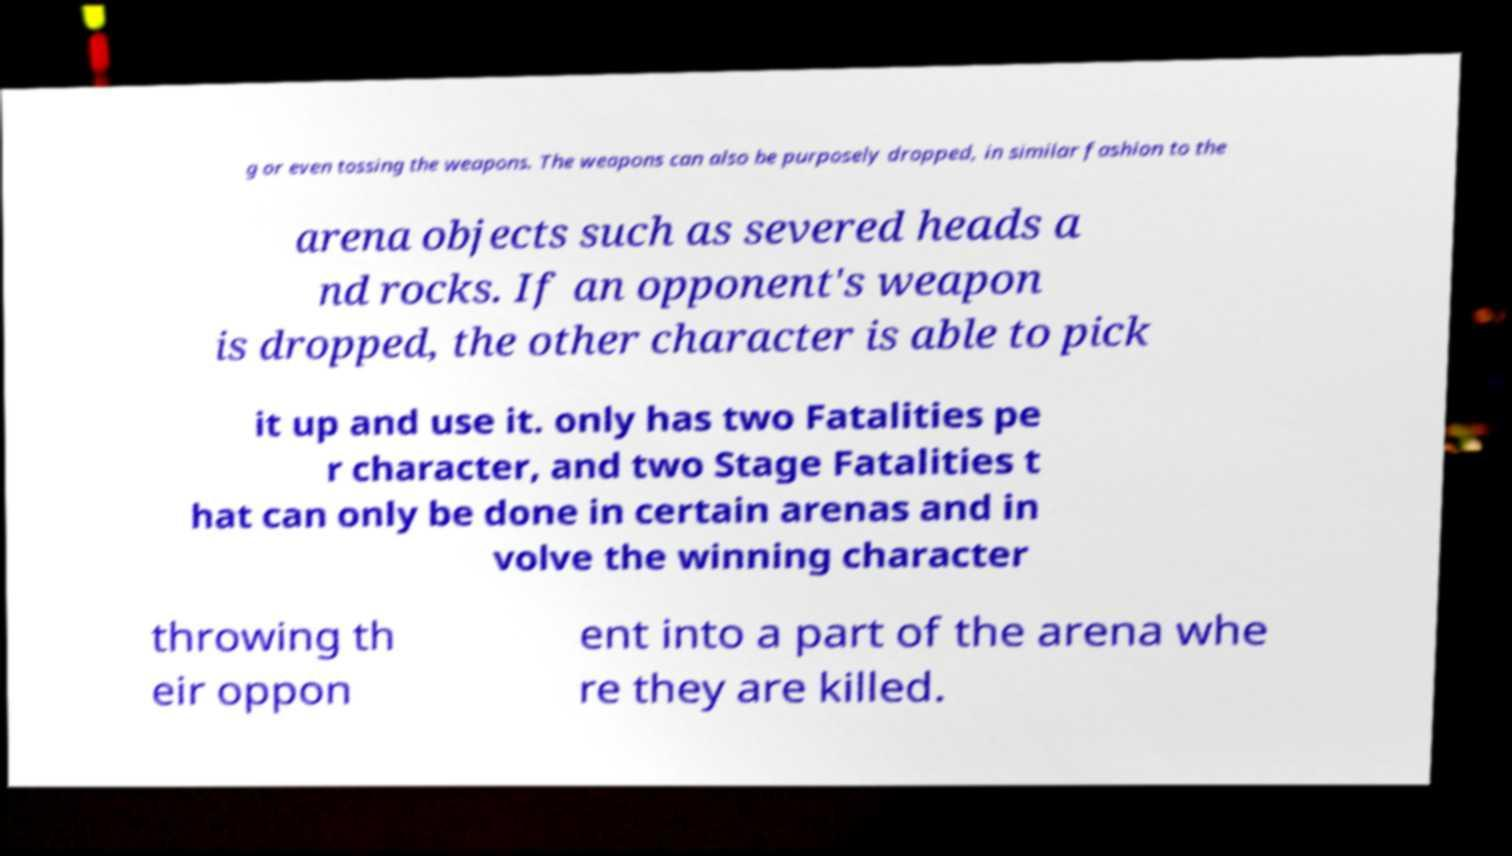For documentation purposes, I need the text within this image transcribed. Could you provide that? g or even tossing the weapons. The weapons can also be purposely dropped, in similar fashion to the arena objects such as severed heads a nd rocks. If an opponent's weapon is dropped, the other character is able to pick it up and use it. only has two Fatalities pe r character, and two Stage Fatalities t hat can only be done in certain arenas and in volve the winning character throwing th eir oppon ent into a part of the arena whe re they are killed. 